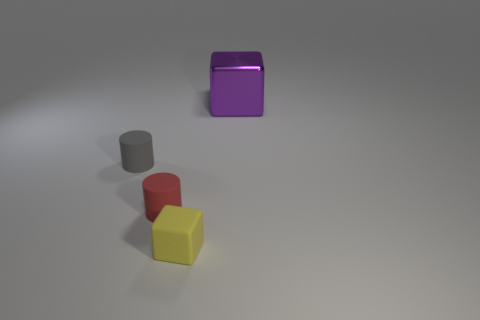Is there any other thing that is the same size as the shiny object?
Give a very brief answer. No. There is a object that is to the right of the cube that is in front of the gray object; what is its shape?
Give a very brief answer. Cube. Is there a yellow thing that has the same size as the red thing?
Your response must be concise. Yes. What number of cyan things are the same shape as the small red thing?
Keep it short and to the point. 0. Are there an equal number of yellow matte blocks that are in front of the small yellow block and gray things that are on the right side of the big object?
Your response must be concise. Yes. Is there a big gray matte object?
Make the answer very short. No. What is the size of the block that is behind the cube on the left side of the thing that is behind the small gray cylinder?
Make the answer very short. Large. What is the shape of the red thing that is the same size as the gray cylinder?
Make the answer very short. Cylinder. Is there any other thing that has the same material as the big thing?
Give a very brief answer. No. What number of things are objects that are in front of the tiny red matte thing or purple shiny things?
Provide a short and direct response. 2. 